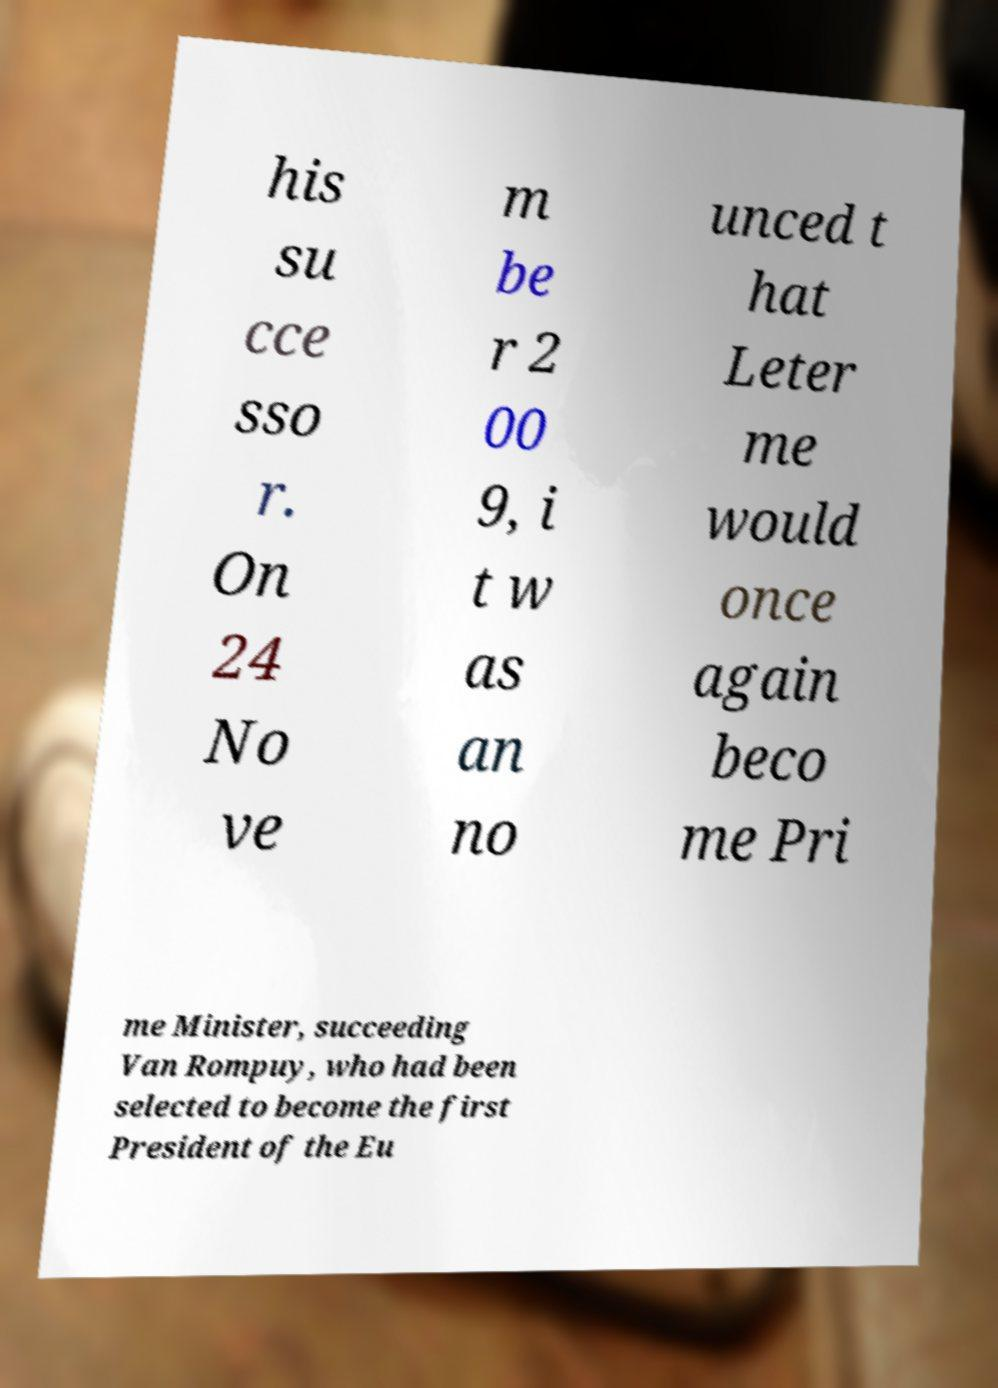Could you extract and type out the text from this image? his su cce sso r. On 24 No ve m be r 2 00 9, i t w as an no unced t hat Leter me would once again beco me Pri me Minister, succeeding Van Rompuy, who had been selected to become the first President of the Eu 